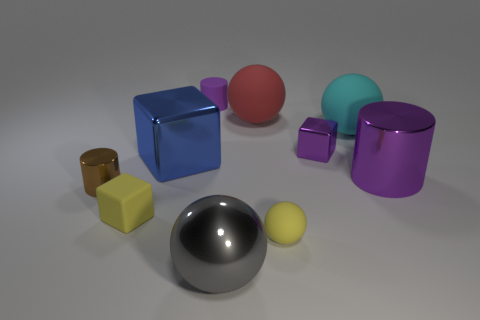What number of objects are either tiny yellow balls or rubber objects?
Ensure brevity in your answer.  5. Is the shape of the cyan rubber object the same as the large purple thing?
Offer a terse response. No. Is there any other thing that is made of the same material as the tiny brown object?
Offer a terse response. Yes. There is a purple cylinder that is on the left side of the cyan matte object; does it have the same size as the yellow object that is to the left of the big red ball?
Provide a short and direct response. Yes. What material is the thing that is both to the right of the tiny purple cylinder and behind the cyan rubber thing?
Give a very brief answer. Rubber. Is there anything else of the same color as the small matte sphere?
Offer a very short reply. Yes. Are there fewer large red rubber objects behind the red sphere than large red metal balls?
Keep it short and to the point. No. Is the number of large gray metal spheres greater than the number of large matte things?
Offer a terse response. No. Is there a small matte thing that is in front of the tiny purple thing behind the small block that is behind the large purple object?
Keep it short and to the point. Yes. What number of other things are there of the same size as the brown metallic object?
Your answer should be compact. 4. 